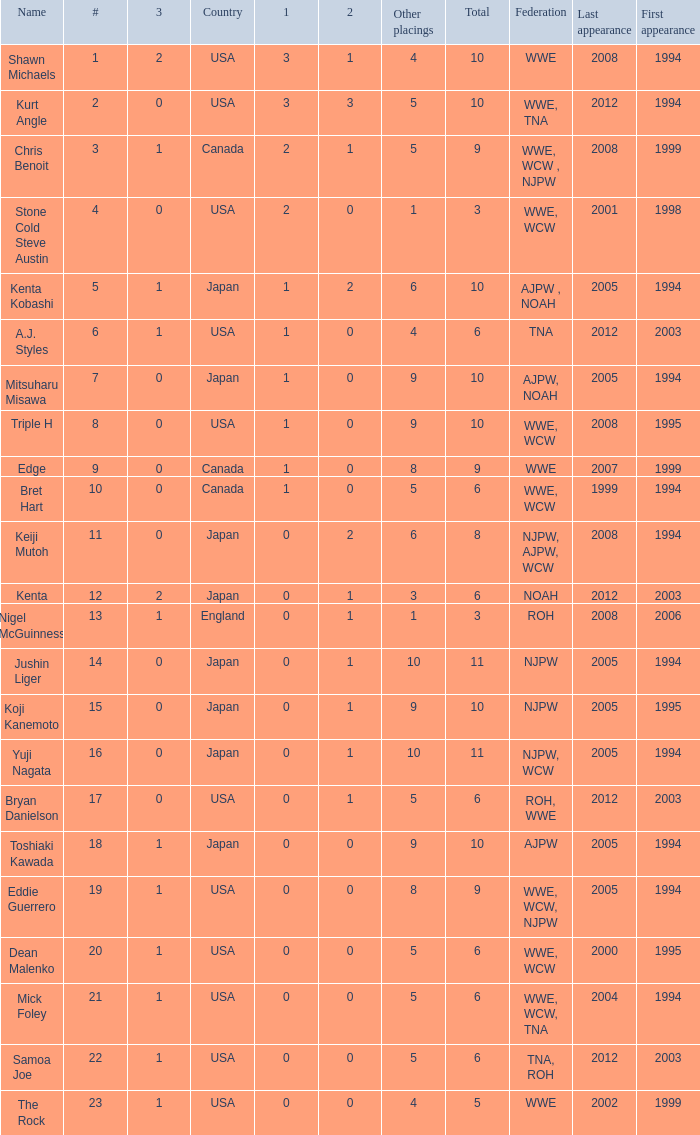How many times has a wrestler whose federation was roh, wwe competed in this event? 1.0. 